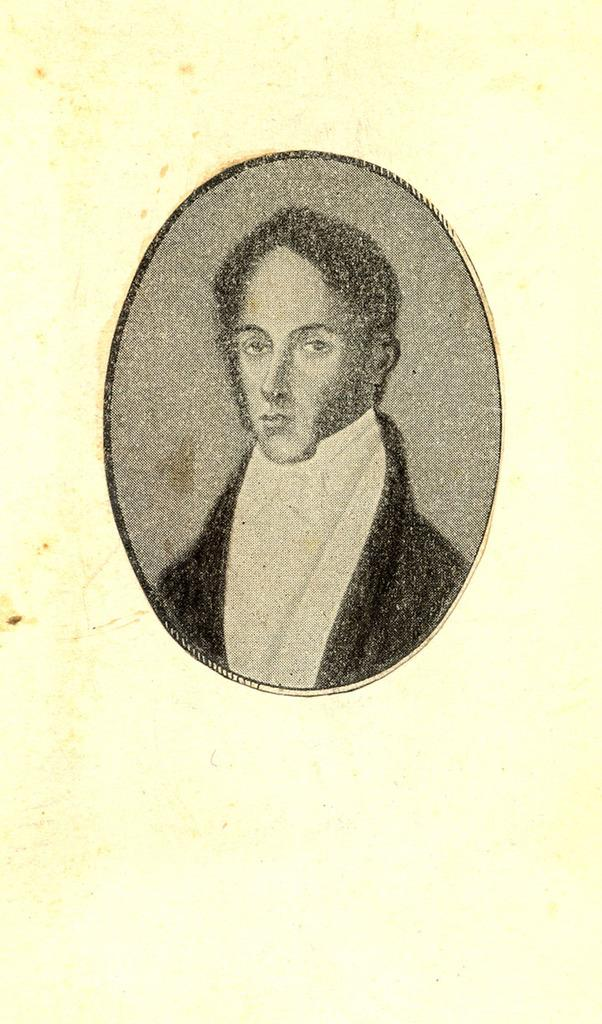What is the main subject of the image? There is a painting in the image. What is depicted in the painting? The painting depicts a man. What is the man wearing in the painting? The man is wearing a black coat and a white shirt. How does the flock of birds contribute to the painting in the image? There are no birds, flock or otherwise, present in the image. The painting only depicts a man wearing a black coat and a white shirt. 